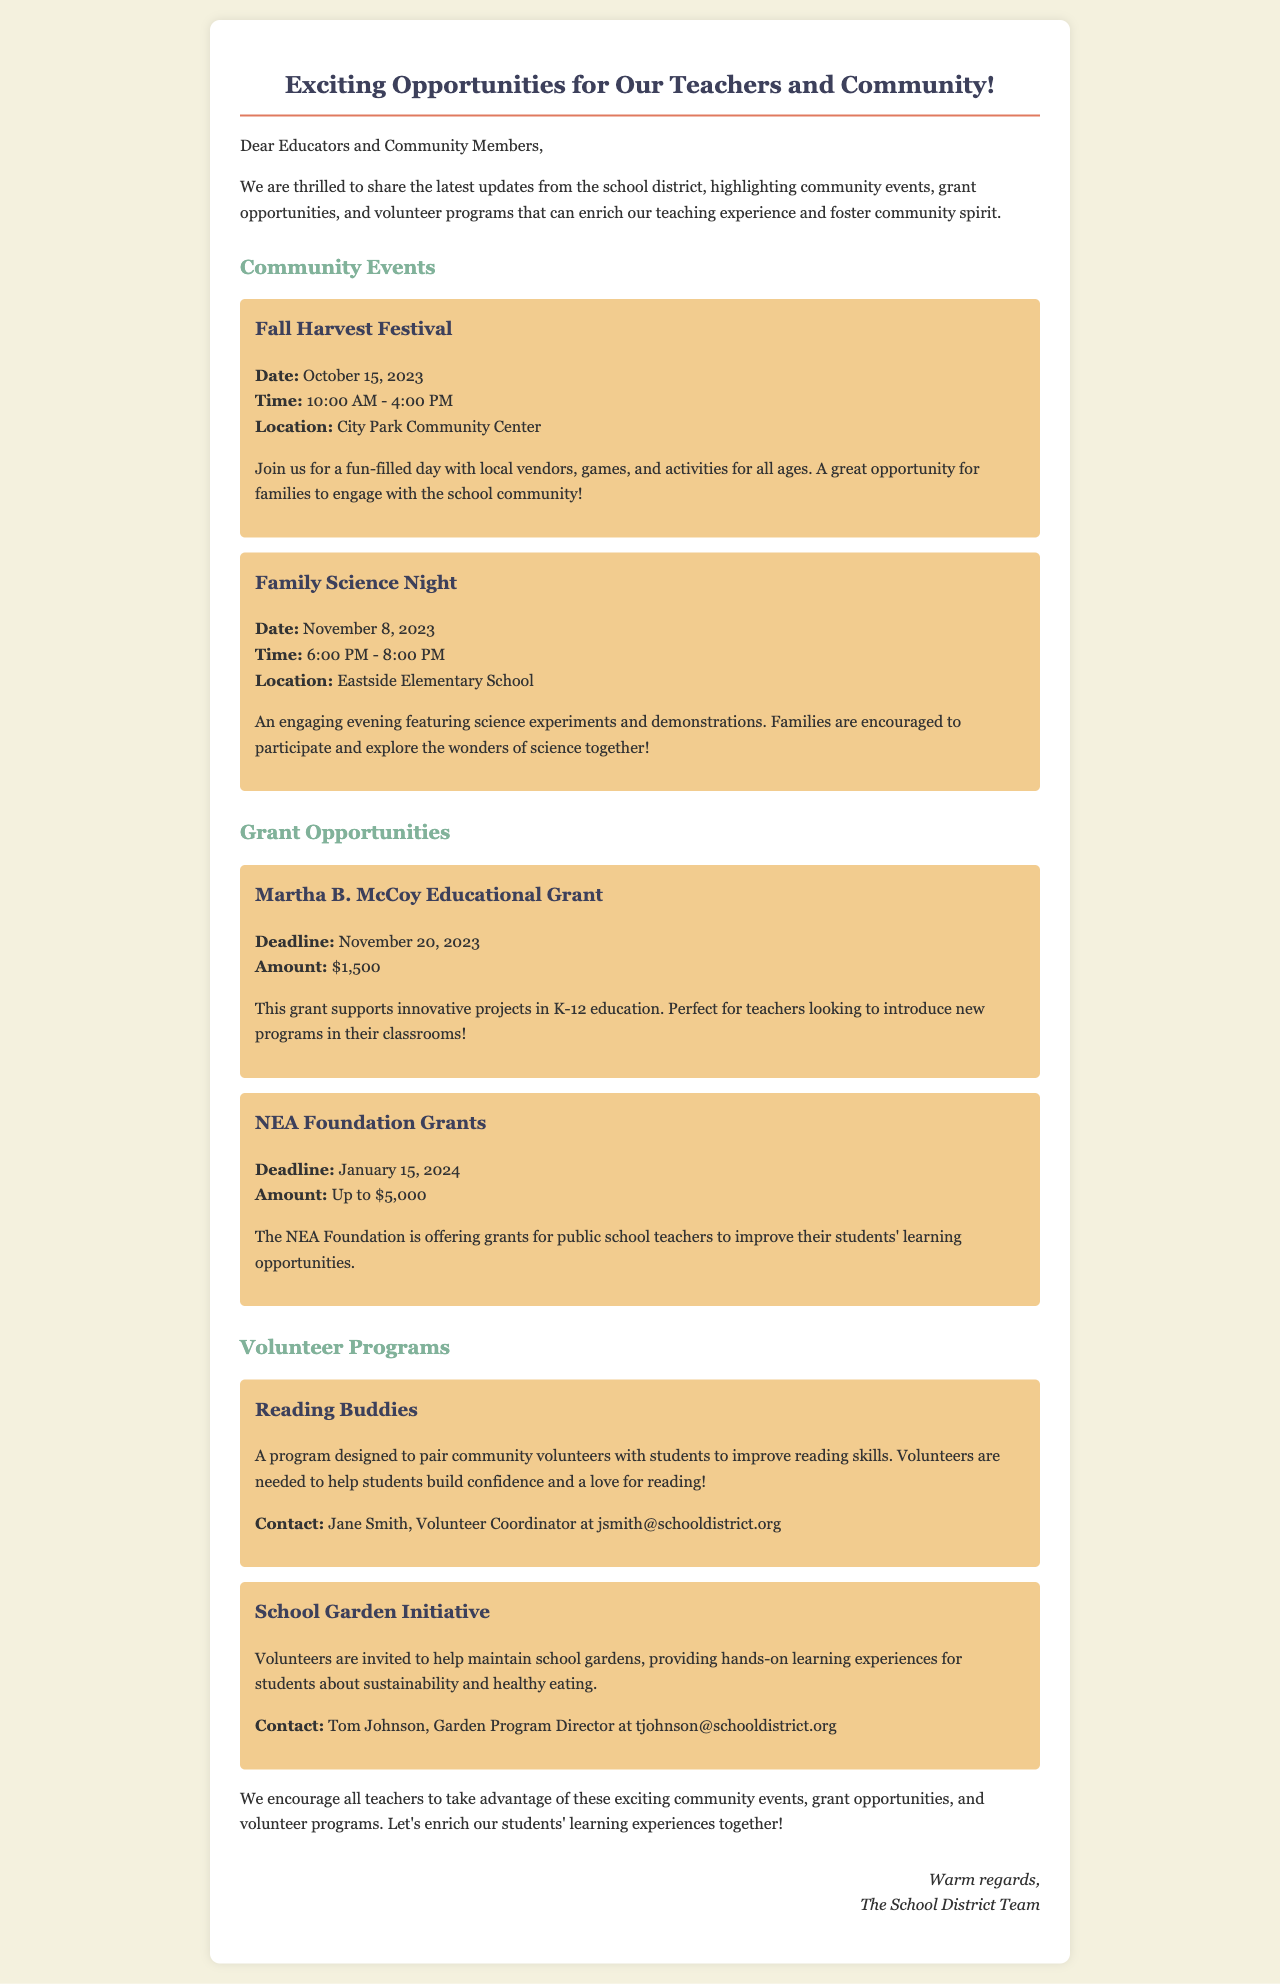what is the date of the Fall Harvest Festival? The Fall Harvest Festival is scheduled for October 15, 2023.
Answer: October 15, 2023 how much is the Martha B. McCoy Educational Grant? The grant amount is specified as $1,500.
Answer: $1,500 who should be contacted for the Reading Buddies program? The document states that Jane Smith is the contact for the Reading Buddies program.
Answer: Jane Smith what is the purpose of the School Garden Initiative? The initiative aims to provide hands-on learning experiences about sustainability and healthy eating.
Answer: Sustainability and healthy eating how many community events are listed in the newsletter? There are two community events mentioned: Fall Harvest Festival and Family Science Night.
Answer: Two 